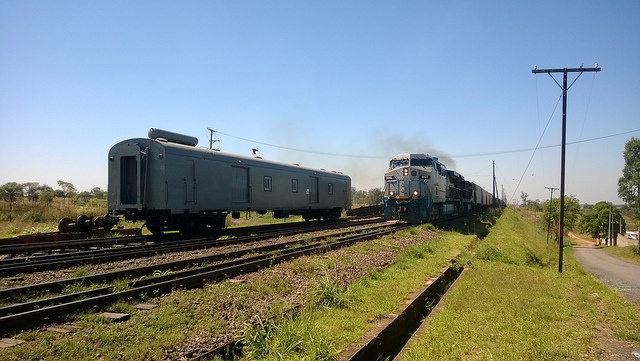Describe the objects in this image and their specific colors. I can see train in lightblue, black, darkblue, and purple tones and train in lightblue, black, gray, darkgray, and blue tones in this image. 